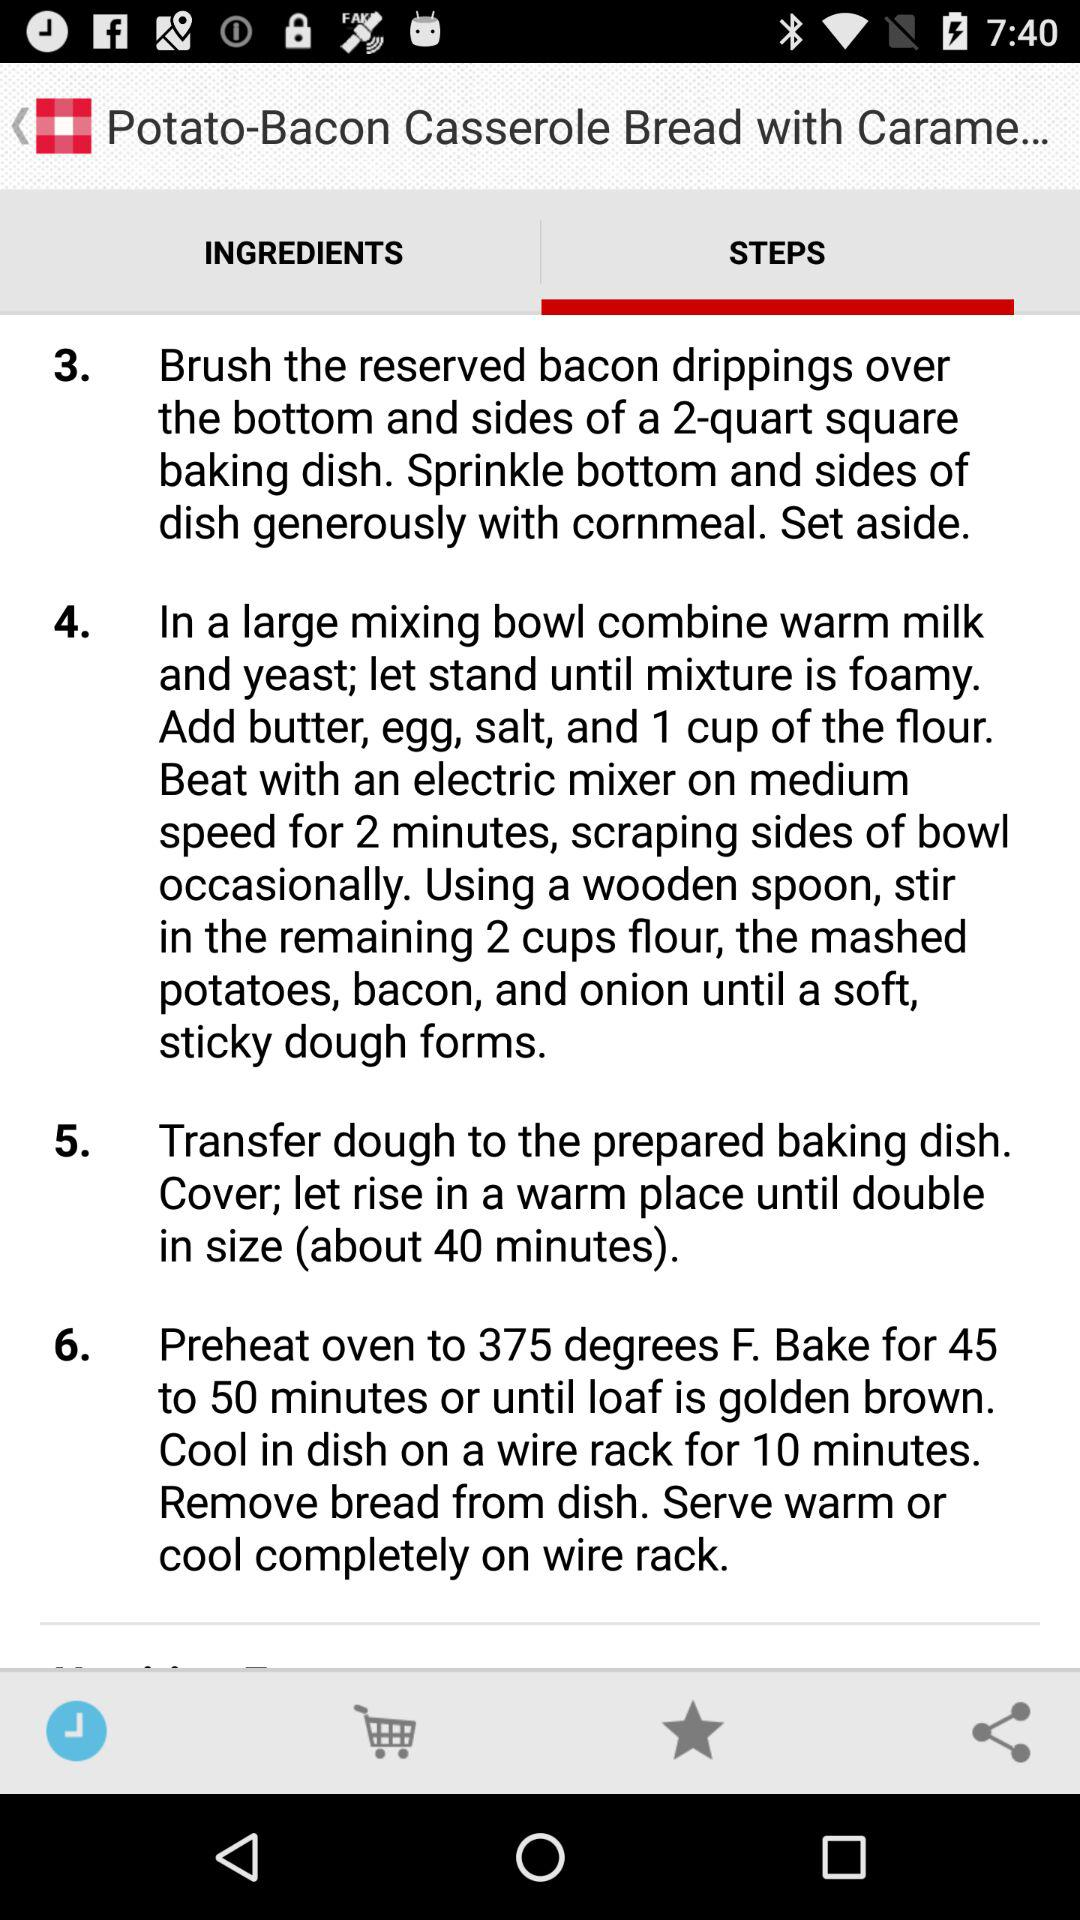How many steps are there in this recipe?
Answer the question using a single word or phrase. 6 